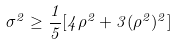<formula> <loc_0><loc_0><loc_500><loc_500>\sigma ^ { 2 } \geq \frac { 1 } { 5 } [ 4 \rho ^ { 2 } + 3 ( \rho ^ { 2 } ) ^ { 2 } ]</formula> 